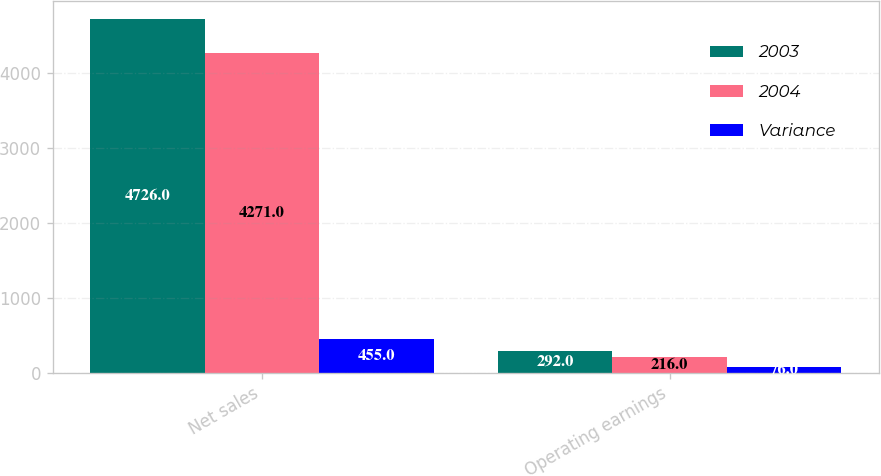Convert chart to OTSL. <chart><loc_0><loc_0><loc_500><loc_500><stacked_bar_chart><ecel><fcel>Net sales<fcel>Operating earnings<nl><fcel>2003<fcel>4726<fcel>292<nl><fcel>2004<fcel>4271<fcel>216<nl><fcel>Variance<fcel>455<fcel>76<nl></chart> 